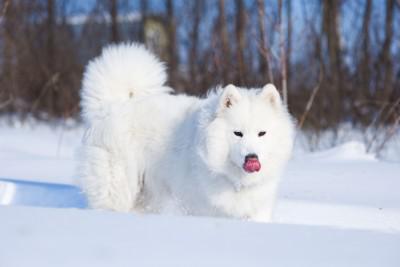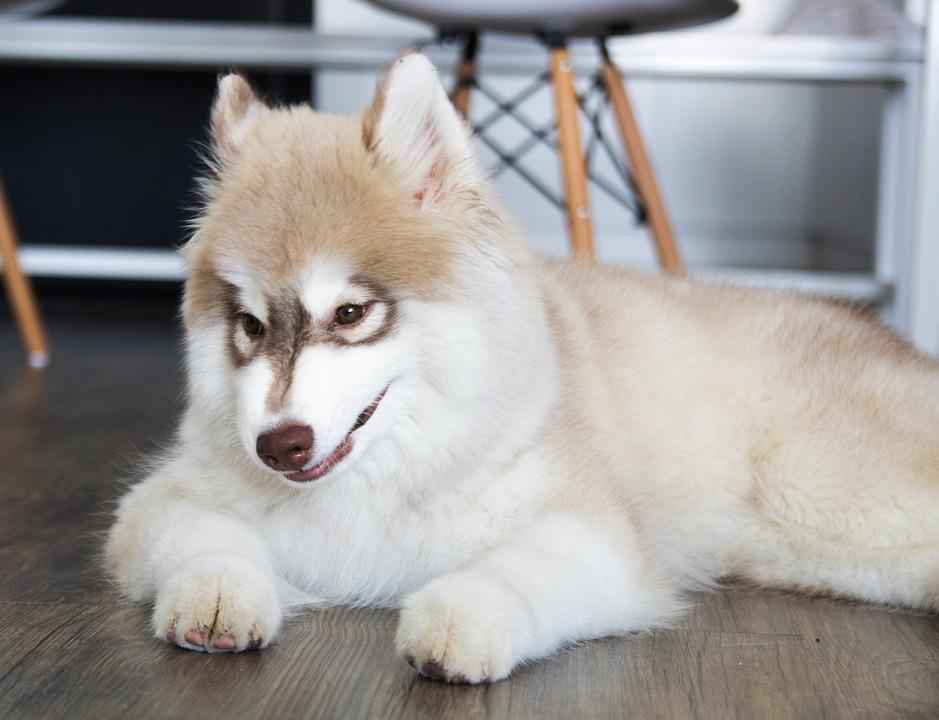The first image is the image on the left, the second image is the image on the right. Evaluate the accuracy of this statement regarding the images: "There are at least two dogs in the image on the right.". Is it true? Answer yes or no. No. The first image is the image on the left, the second image is the image on the right. For the images shown, is this caption "A white dog is outside in the snow." true? Answer yes or no. Yes. 